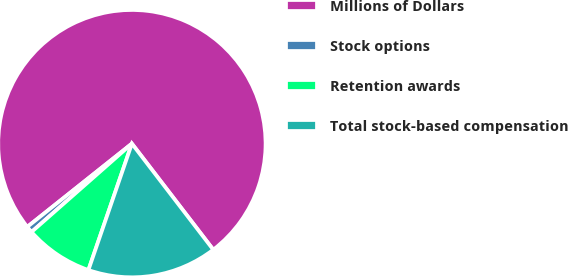Convert chart to OTSL. <chart><loc_0><loc_0><loc_500><loc_500><pie_chart><fcel>Millions of Dollars<fcel>Stock options<fcel>Retention awards<fcel>Total stock-based compensation<nl><fcel>75.29%<fcel>0.79%<fcel>8.24%<fcel>15.69%<nl></chart> 